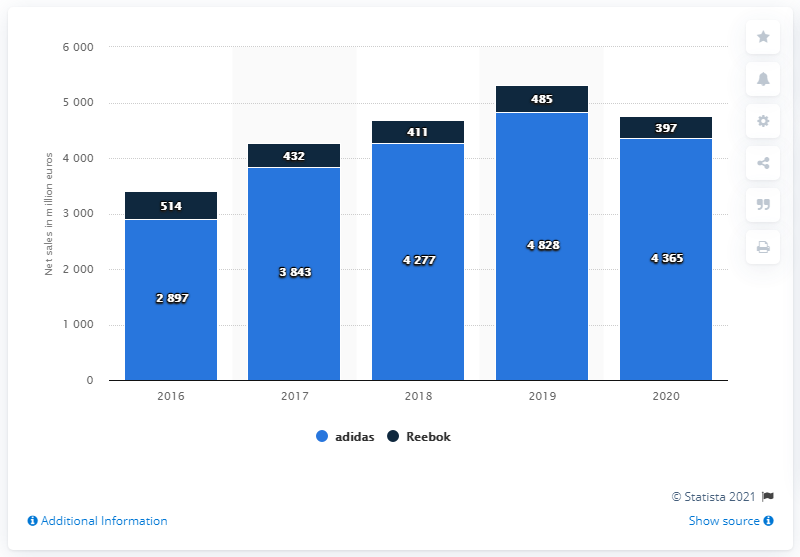Highlight a few significant elements in this photo. In 2020, the adidas brand generated approximately $4,365 in net sales in North America. 